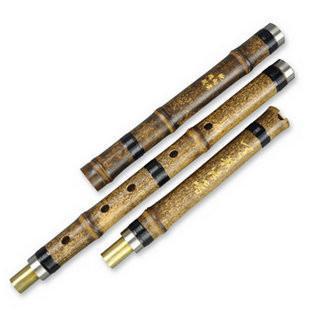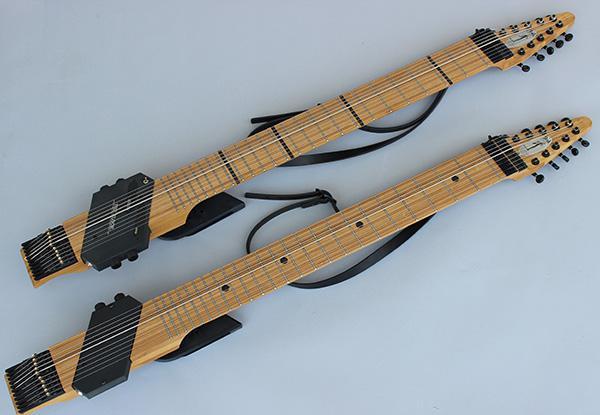The first image is the image on the left, the second image is the image on the right. For the images displayed, is the sentence "There are two flutes in the left image." factually correct? Answer yes or no. No. The first image is the image on the left, the second image is the image on the right. Given the left and right images, does the statement "One image shows two diagonally displayed, side-by-side wooden flutes, and the other image shows at least one hole in a single wooden flute." hold true? Answer yes or no. No. 